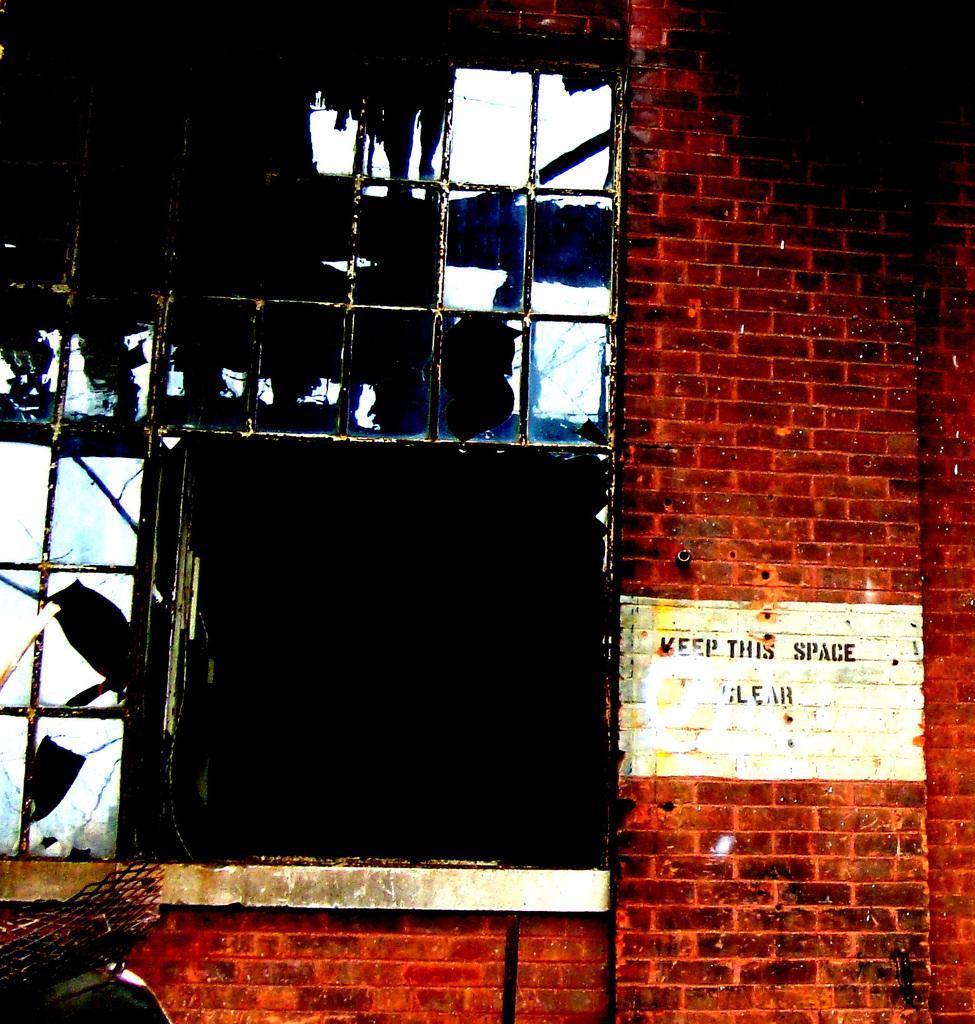Please provide a concise description of this image. In this image we can see a wall with some text on it and a window. On the left side we can see the mesh. 